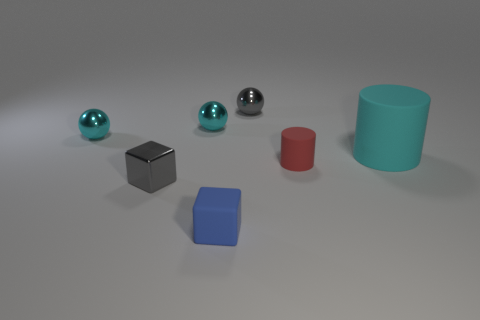Add 2 large spheres. How many objects exist? 9 Subtract all blocks. How many objects are left? 5 Add 2 tiny rubber cylinders. How many tiny rubber cylinders are left? 3 Add 7 big brown cylinders. How many big brown cylinders exist? 7 Subtract 0 green blocks. How many objects are left? 7 Subtract all cyan spheres. Subtract all tiny blue rubber objects. How many objects are left? 4 